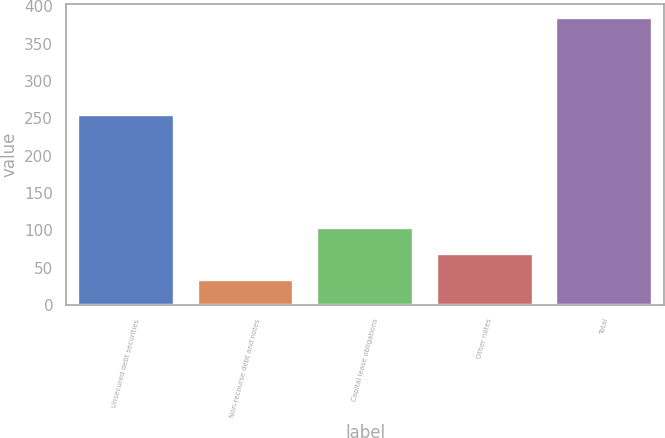Convert chart to OTSL. <chart><loc_0><loc_0><loc_500><loc_500><bar_chart><fcel>Unsecured debt securities<fcel>Non-recourse debt and notes<fcel>Capital lease obligations<fcel>Other notes<fcel>Total<nl><fcel>255<fcel>33<fcel>103.2<fcel>68.1<fcel>384<nl></chart> 